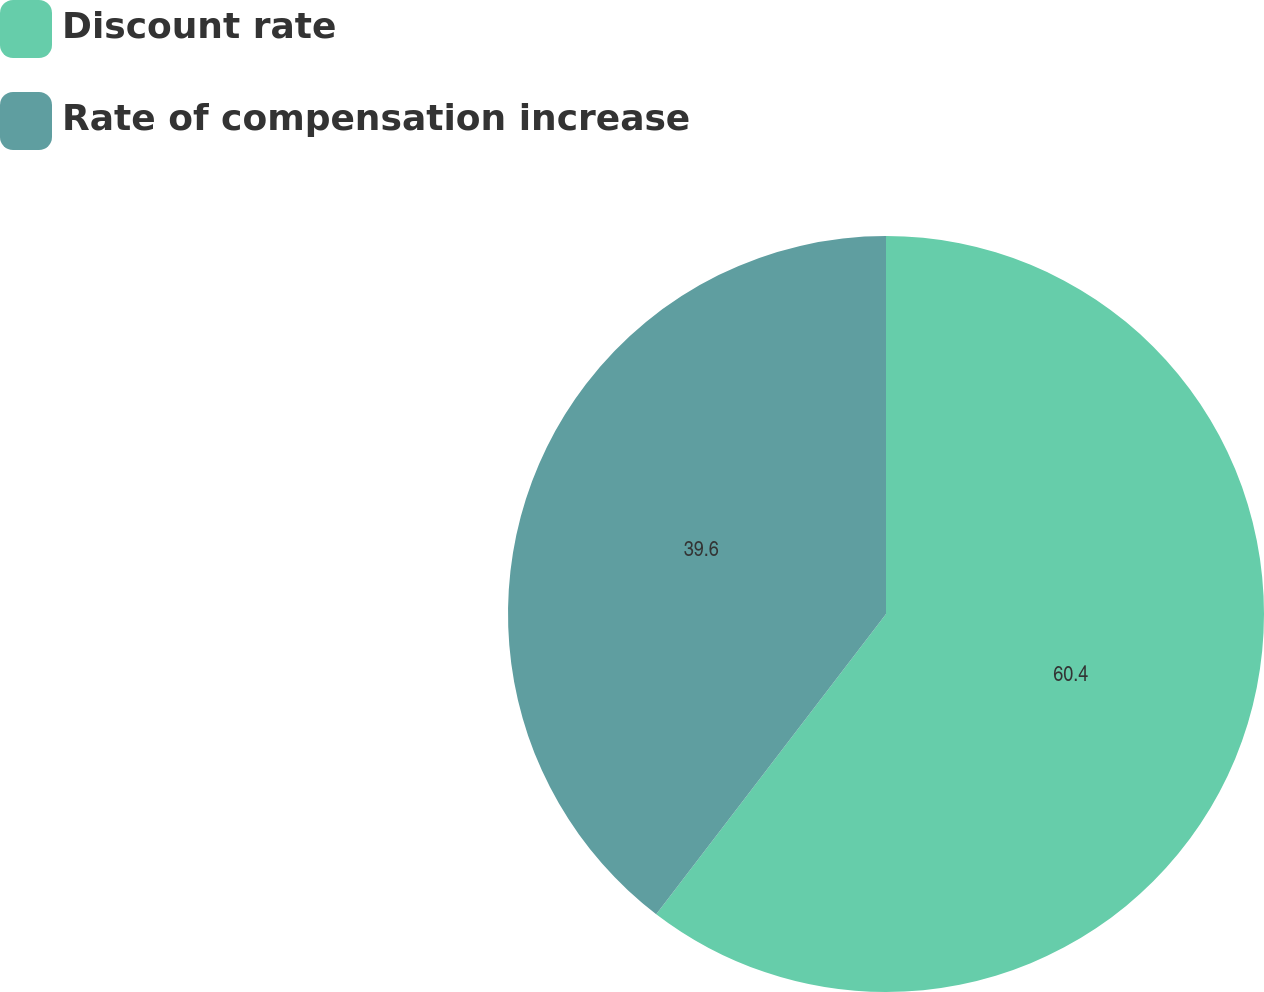Convert chart. <chart><loc_0><loc_0><loc_500><loc_500><pie_chart><fcel>Discount rate<fcel>Rate of compensation increase<nl><fcel>60.4%<fcel>39.6%<nl></chart> 